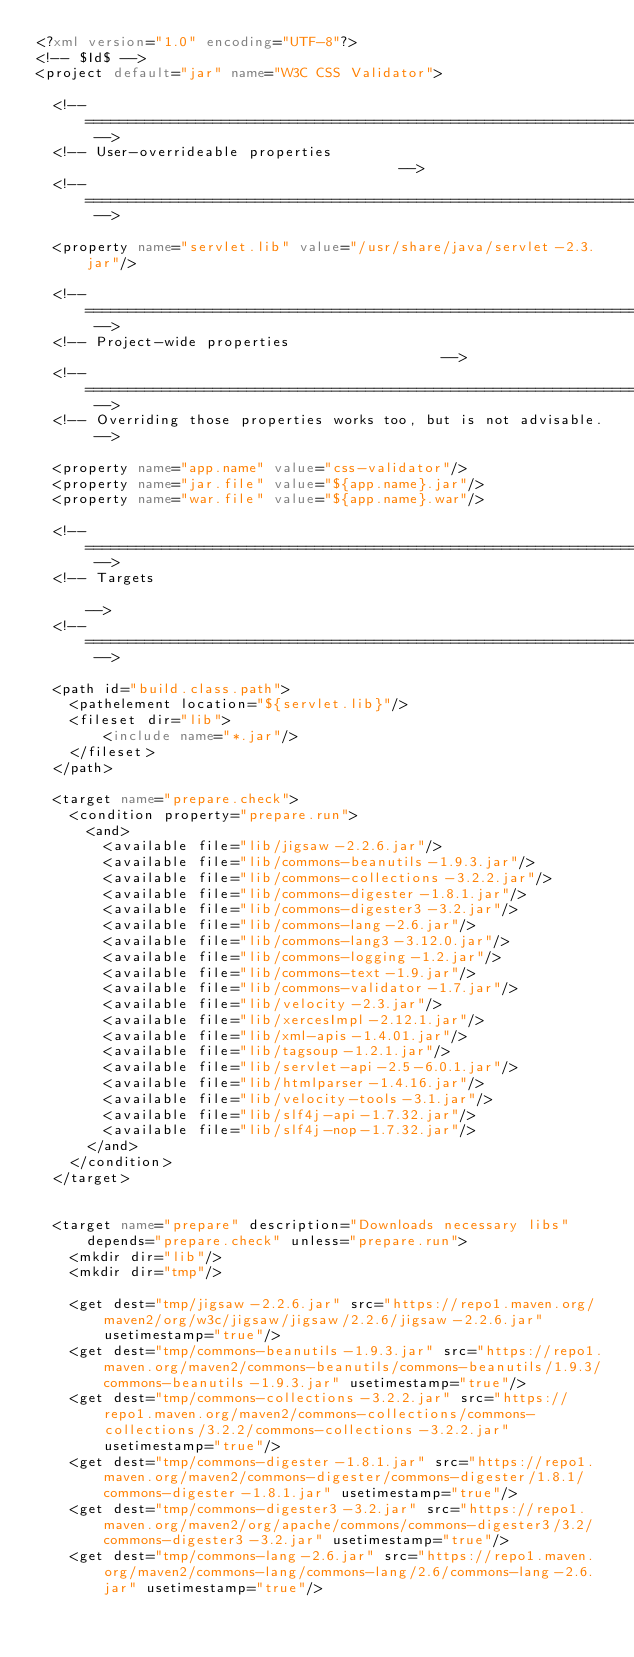<code> <loc_0><loc_0><loc_500><loc_500><_XML_><?xml version="1.0" encoding="UTF-8"?>
<!-- $Id$ -->
<project default="jar" name="W3C CSS Validator">

  <!-- =================================================================== -->
  <!-- User-overrideable properties                                      -->
  <!-- =================================================================== -->

  <property name="servlet.lib" value="/usr/share/java/servlet-2.3.jar"/>

  <!-- =================================================================== -->
  <!-- Project-wide properties                                           -->
  <!-- =================================================================== -->
  <!-- Overriding those properties works too, but is not advisable. -->

  <property name="app.name" value="css-validator"/>
  <property name="jar.file" value="${app.name}.jar"/>
  <property name="war.file" value="${app.name}.war"/>

  <!-- =================================================================== -->
  <!-- Targets                                                             -->
  <!-- =================================================================== -->

  <path id="build.class.path">
    <pathelement location="${servlet.lib}"/>
    <fileset dir="lib">
        <include name="*.jar"/>
    </fileset>
  </path>

  <target name="prepare.check">
    <condition property="prepare.run">
      <and>
        <available file="lib/jigsaw-2.2.6.jar"/>
        <available file="lib/commons-beanutils-1.9.3.jar"/>
        <available file="lib/commons-collections-3.2.2.jar"/>
        <available file="lib/commons-digester-1.8.1.jar"/>
        <available file="lib/commons-digester3-3.2.jar"/>
        <available file="lib/commons-lang-2.6.jar"/>
        <available file="lib/commons-lang3-3.12.0.jar"/>
        <available file="lib/commons-logging-1.2.jar"/>
        <available file="lib/commons-text-1.9.jar"/>
        <available file="lib/commons-validator-1.7.jar"/>
        <available file="lib/velocity-2.3.jar"/>
        <available file="lib/xercesImpl-2.12.1.jar"/>
        <available file="lib/xml-apis-1.4.01.jar"/>
        <available file="lib/tagsoup-1.2.1.jar"/>
        <available file="lib/servlet-api-2.5-6.0.1.jar"/>
        <available file="lib/htmlparser-1.4.16.jar"/>
        <available file="lib/velocity-tools-3.1.jar"/>
        <available file="lib/slf4j-api-1.7.32.jar"/>
        <available file="lib/slf4j-nop-1.7.32.jar"/>
      </and>
    </condition>
  </target>


  <target name="prepare" description="Downloads necessary libs" depends="prepare.check" unless="prepare.run">
    <mkdir dir="lib"/>
    <mkdir dir="tmp"/>

    <get dest="tmp/jigsaw-2.2.6.jar" src="https://repo1.maven.org/maven2/org/w3c/jigsaw/jigsaw/2.2.6/jigsaw-2.2.6.jar" usetimestamp="true"/>
    <get dest="tmp/commons-beanutils-1.9.3.jar" src="https://repo1.maven.org/maven2/commons-beanutils/commons-beanutils/1.9.3/commons-beanutils-1.9.3.jar" usetimestamp="true"/>
    <get dest="tmp/commons-collections-3.2.2.jar" src="https://repo1.maven.org/maven2/commons-collections/commons-collections/3.2.2/commons-collections-3.2.2.jar" usetimestamp="true"/>
    <get dest="tmp/commons-digester-1.8.1.jar" src="https://repo1.maven.org/maven2/commons-digester/commons-digester/1.8.1/commons-digester-1.8.1.jar" usetimestamp="true"/>
    <get dest="tmp/commons-digester3-3.2.jar" src="https://repo1.maven.org/maven2/org/apache/commons/commons-digester3/3.2/commons-digester3-3.2.jar" usetimestamp="true"/>
    <get dest="tmp/commons-lang-2.6.jar" src="https://repo1.maven.org/maven2/commons-lang/commons-lang/2.6/commons-lang-2.6.jar" usetimestamp="true"/></code> 